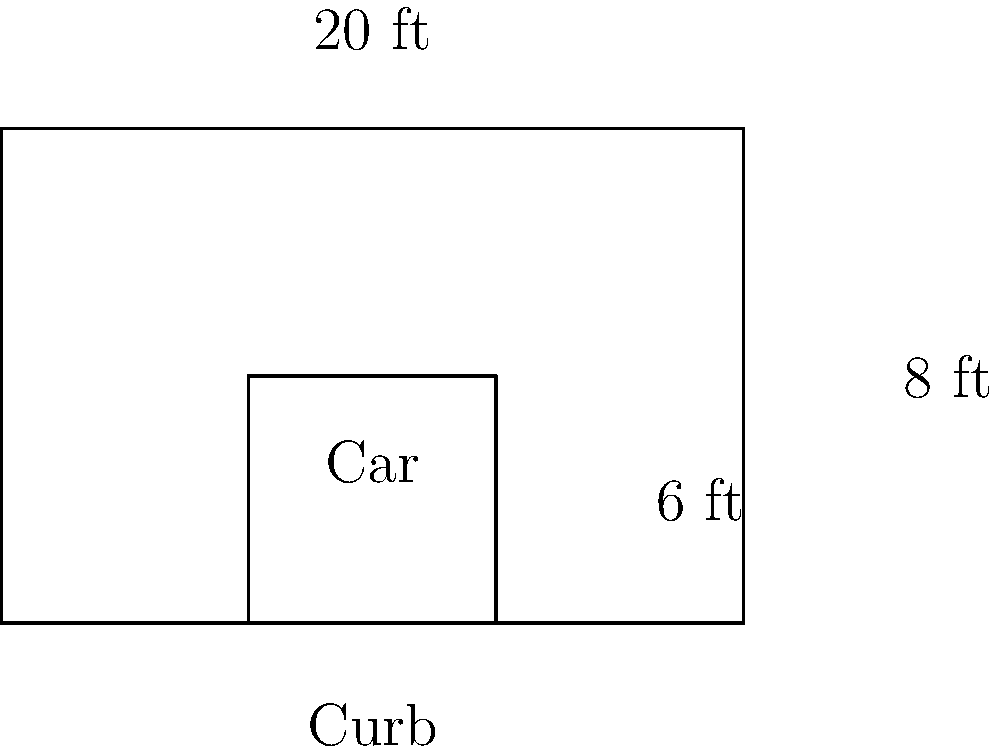A parallel parking space is 20 feet long and 8 feet wide. If a car occupies a rectangular area that is 6 feet wide and 14 feet long, what is the maximum number of congruent cars that can fit in this parking space, assuming perfect parallel parking and no space between cars? To solve this problem, we need to follow these steps:

1) First, we need to understand that the cars must be parked parallel to the curb, which means their 6-foot width will align with the 8-foot width of the parking space.

2) The length of the parking space (20 feet) is the crucial dimension for determining how many cars can fit.

3) Each car is 14 feet long.

4) To find how many cars can fit, we need to divide the length of the parking space by the length of each car:

   $$ \text{Number of cars} = \frac{\text{Length of parking space}}{\text{Length of each car}} $$

5) Substituting the values:

   $$ \text{Number of cars} = \frac{20 \text{ feet}}{14 \text{ feet}} \approx 1.43 $$

6) Since we can't have a fraction of a car, we need to round down to the nearest whole number.

Therefore, the maximum number of congruent cars that can fit in this parking space is 1.
Answer: 1 car 